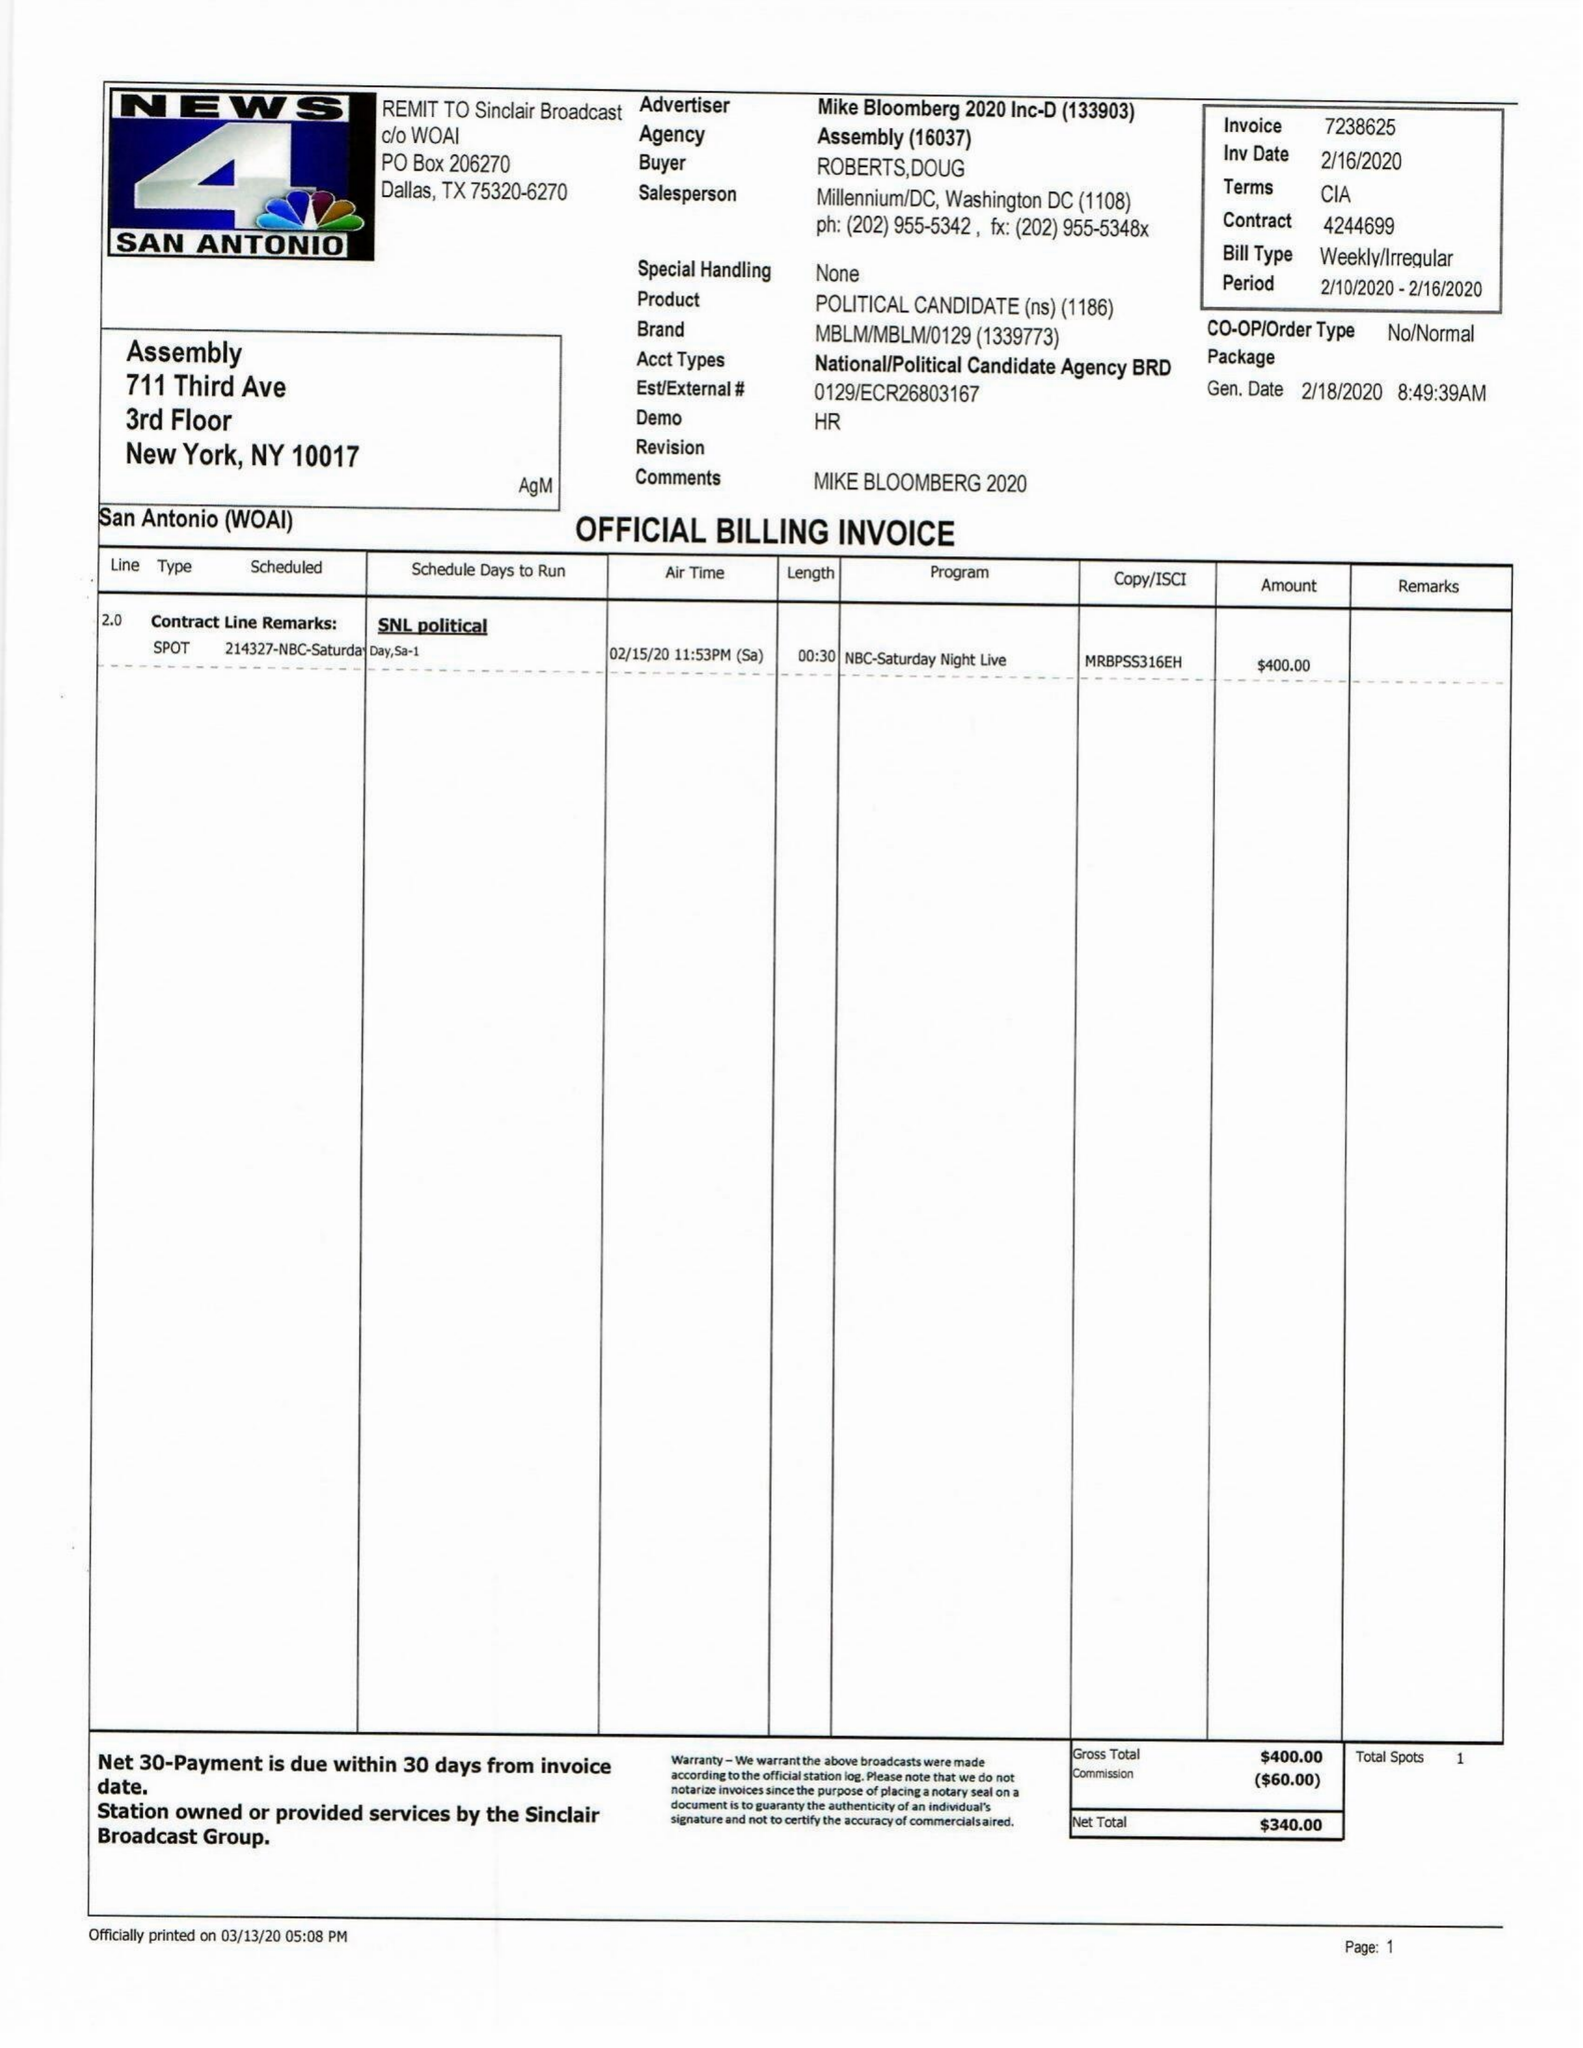What is the value for the advertiser?
Answer the question using a single word or phrase. MIKEBLOOMBERG2020INC-D 